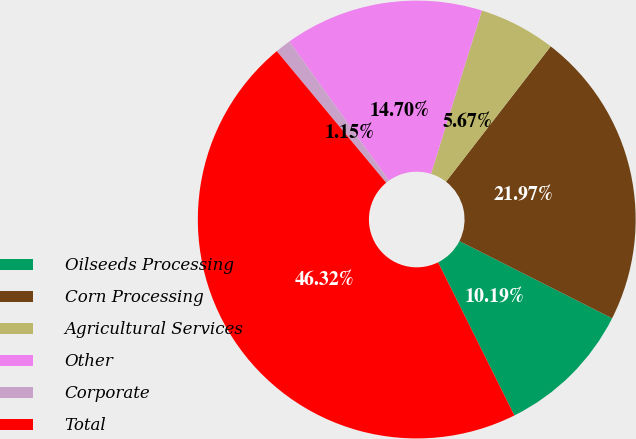Convert chart to OTSL. <chart><loc_0><loc_0><loc_500><loc_500><pie_chart><fcel>Oilseeds Processing<fcel>Corn Processing<fcel>Agricultural Services<fcel>Other<fcel>Corporate<fcel>Total<nl><fcel>10.19%<fcel>21.97%<fcel>5.67%<fcel>14.7%<fcel>1.15%<fcel>46.32%<nl></chart> 